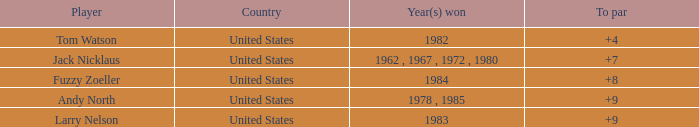What is the overall score of the player with a to par of 4? 1.0. 